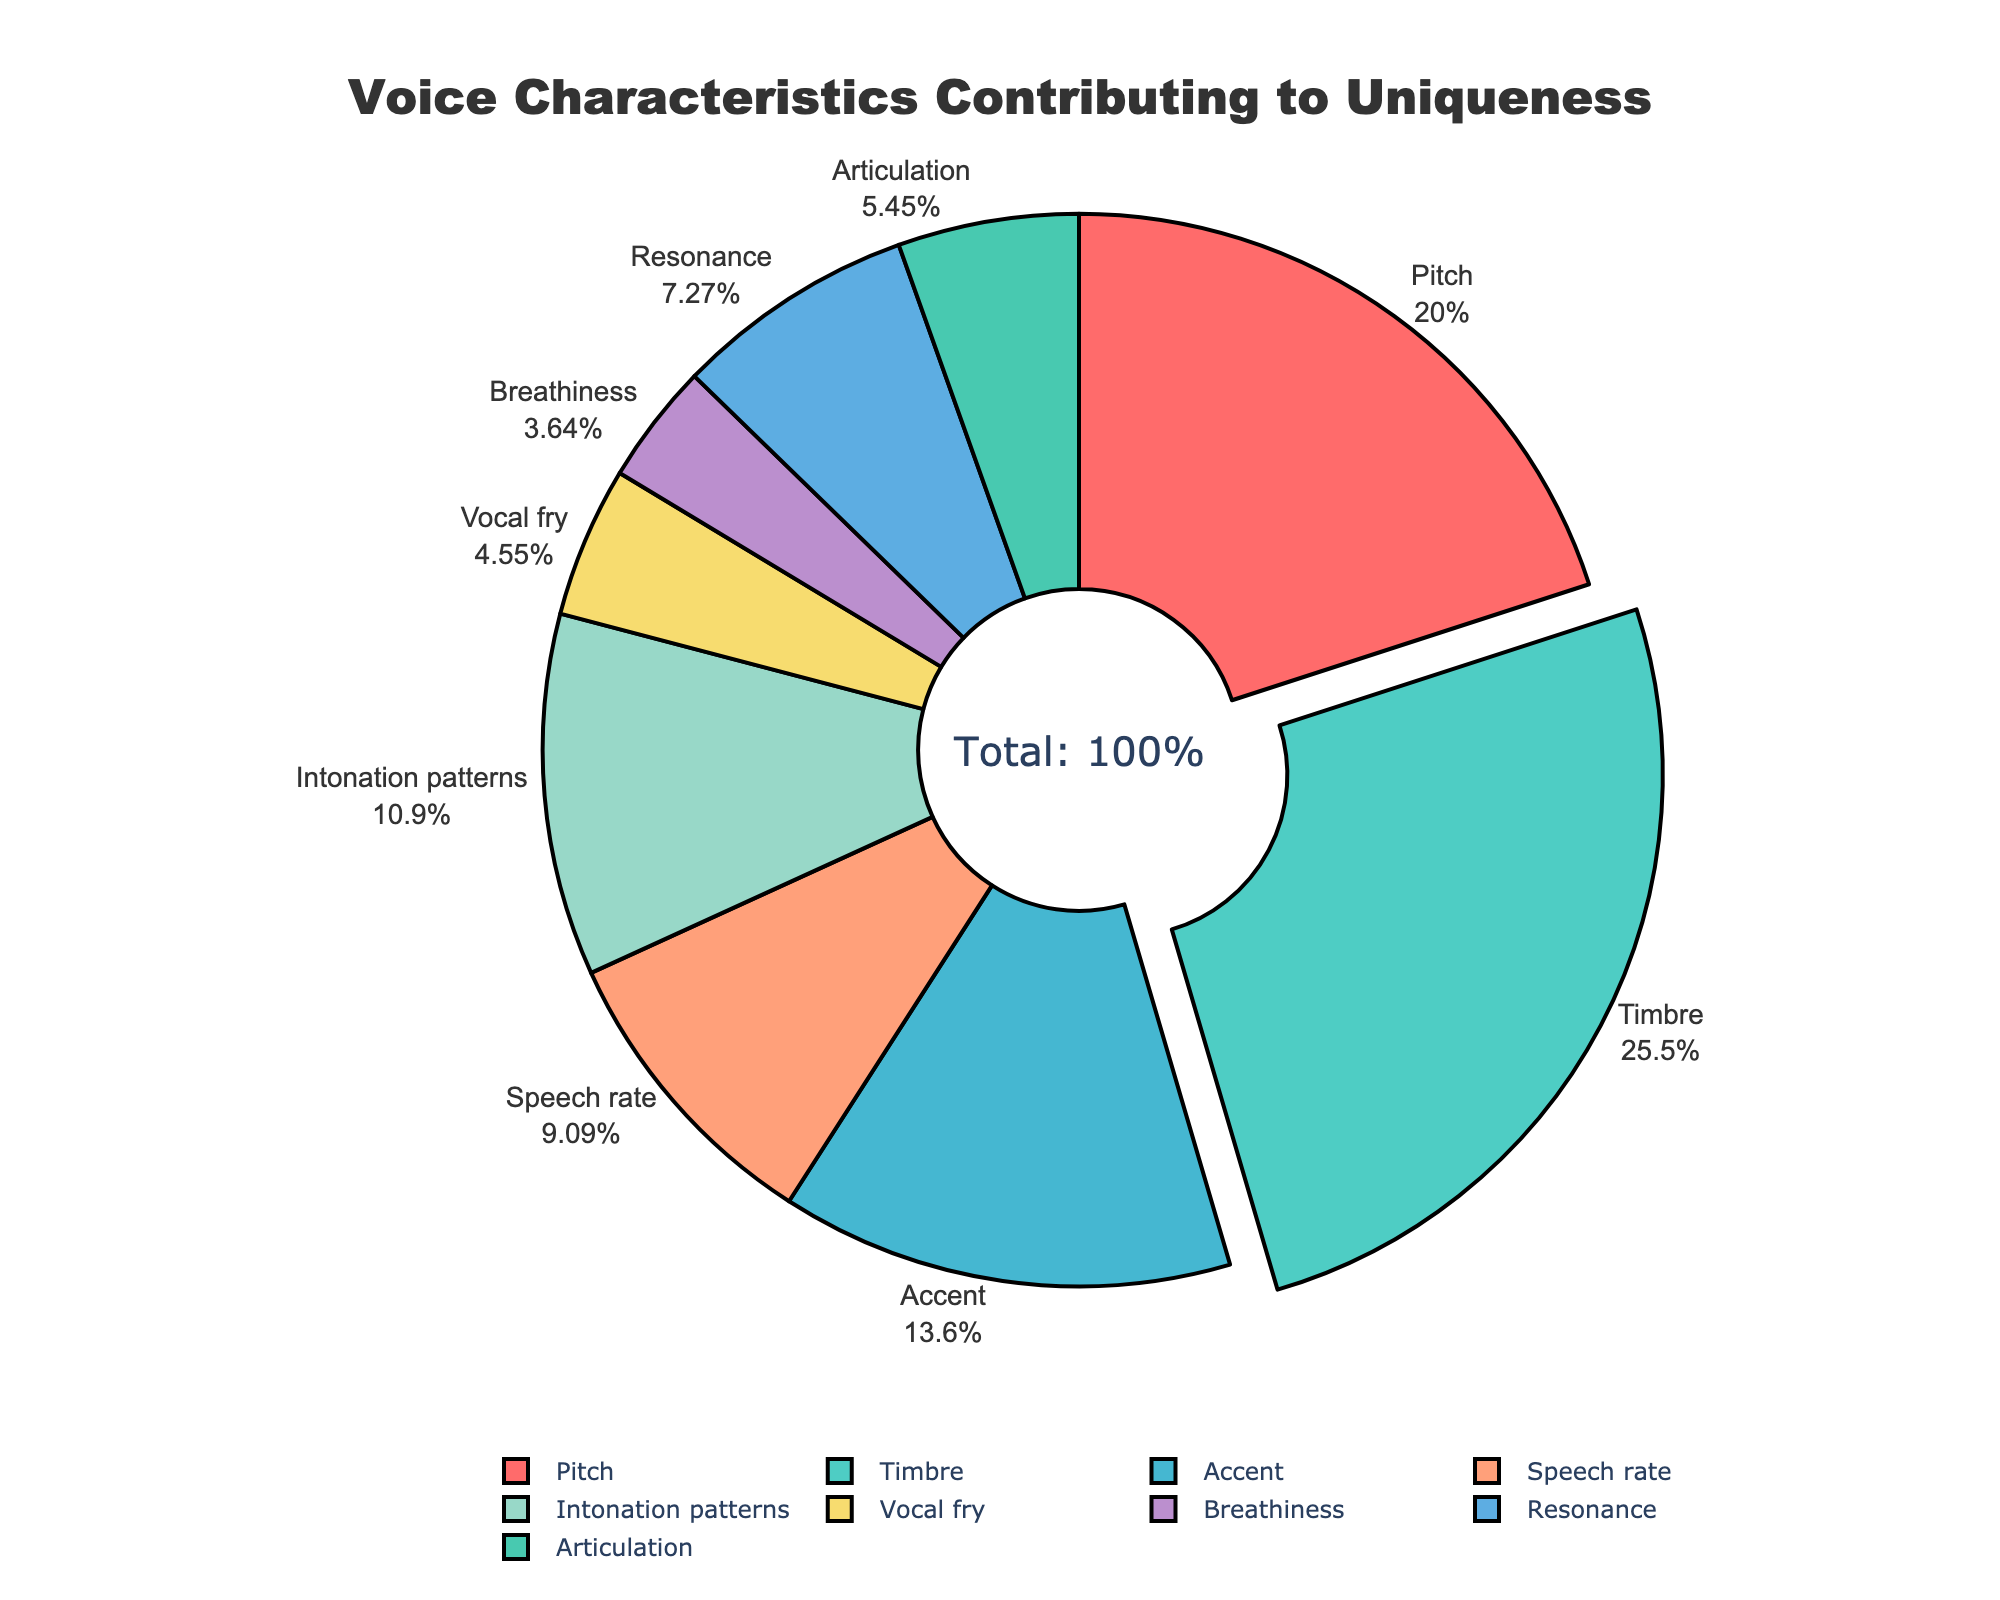Which characteristic contributes the most to voice uniqueness? The largest segment in the pie chart represents Timbre, which thus contributes the most to voice uniqueness at 28%.
Answer: Timbre What percentage of the total is contributed by Pitch and Resonance combined? Add the percentages of Pitch (22%) and Resonance (8%) to get the total contribution: 22% + 8% = 30%.
Answer: 30% Which characteristic has the smallest contribution to voice uniqueness? The smallest segment in the pie chart represents Breathiness, which contributes 4% to voice uniqueness.
Answer: Breathiness How much more does Timbre contribute than Accent? Subtract the percentage of Accent (15%) from the percentage of Timbre (28%) to find the difference: 28% - 15% = 13%.
Answer: 13% What is the combined contribution of non-primary characteristics (Speech rate, Intonation patterns, Vocal fry, Breathiness, Resonance, and Articulation)? Add the percentages of all non-primary characteristics: 10% (Speech rate) + 12% (Intonation patterns) + 5% (Vocal fry) + 4% (Breathiness) + 8% (Resonance) + 6% (Articulation) = 45%.
Answer: 45% Which characteristic is represented by the green color in the pie chart? Observe the segments of the pie chart and identify the characteristic represented by green, which is Timbre.
Answer: Timbre Which two characteristics together amount to one-third of the total contribution? Identify combinations of percentages that sum up to roughly 33%. Here, Pitch (22%) and Intonation patterns (12%) combined contribute 34%, which is closest to one-third.
Answer: Pitch and Intonation patterns How do the contributions of Breathiness and Vocal fry compare? Compare the percentages of Breathiness (4%) and Vocal fry (5%); Vocal fry contributes slightly more than Breathiness.
Answer: Vocal fry contributes more What is the average percentage contribution of Pitch, Timbre, and Accent? Calculate the average of the percentages for Pitch (22%), Timbre (28%), and Accent (15%): (22% + 28% + 15%) / 3 = 21.67%.
Answer: 21.67% If Timbre's contribution increased by 5 percentage points, what would its new percentage be? Add 5 percentage points to Timbre's current percentage: 28% + 5% = 33%.
Answer: 33% 